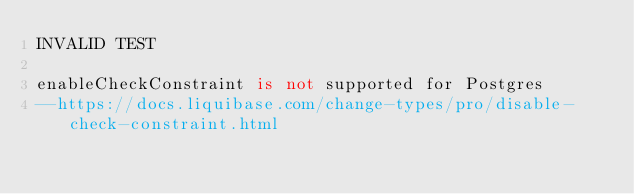Convert code to text. <code><loc_0><loc_0><loc_500><loc_500><_SQL_>INVALID TEST

enableCheckConstraint is not supported for Postgres
--https://docs.liquibase.com/change-types/pro/disable-check-constraint.html</code> 